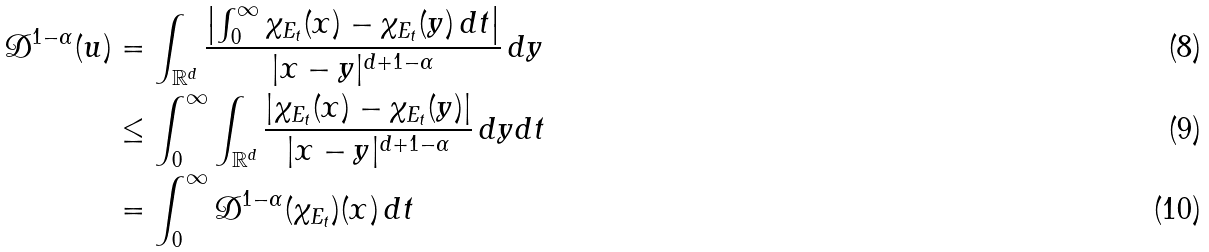<formula> <loc_0><loc_0><loc_500><loc_500>\mathcal { D } ^ { 1 - \alpha } ( u ) & = \int _ { \mathbb { R } ^ { d } } \frac { \left | \int _ { 0 } ^ { \infty } \chi _ { E _ { t } } ( x ) - \chi _ { E _ { t } } ( y ) \, d t \right | } { | x - y | ^ { d + 1 - \alpha } } \, d y \\ & \leq \int _ { 0 } ^ { \infty } \int _ { \mathbb { R } ^ { d } } \frac { | \chi _ { E _ { t } } ( x ) - \chi _ { E _ { t } } ( y ) | } { | x - y | ^ { d + 1 - \alpha } } \, d y d t \\ & = \int _ { 0 } ^ { \infty } \mathcal { D } ^ { 1 - \alpha } ( \chi _ { E _ { t } } ) ( x ) \, d t</formula> 